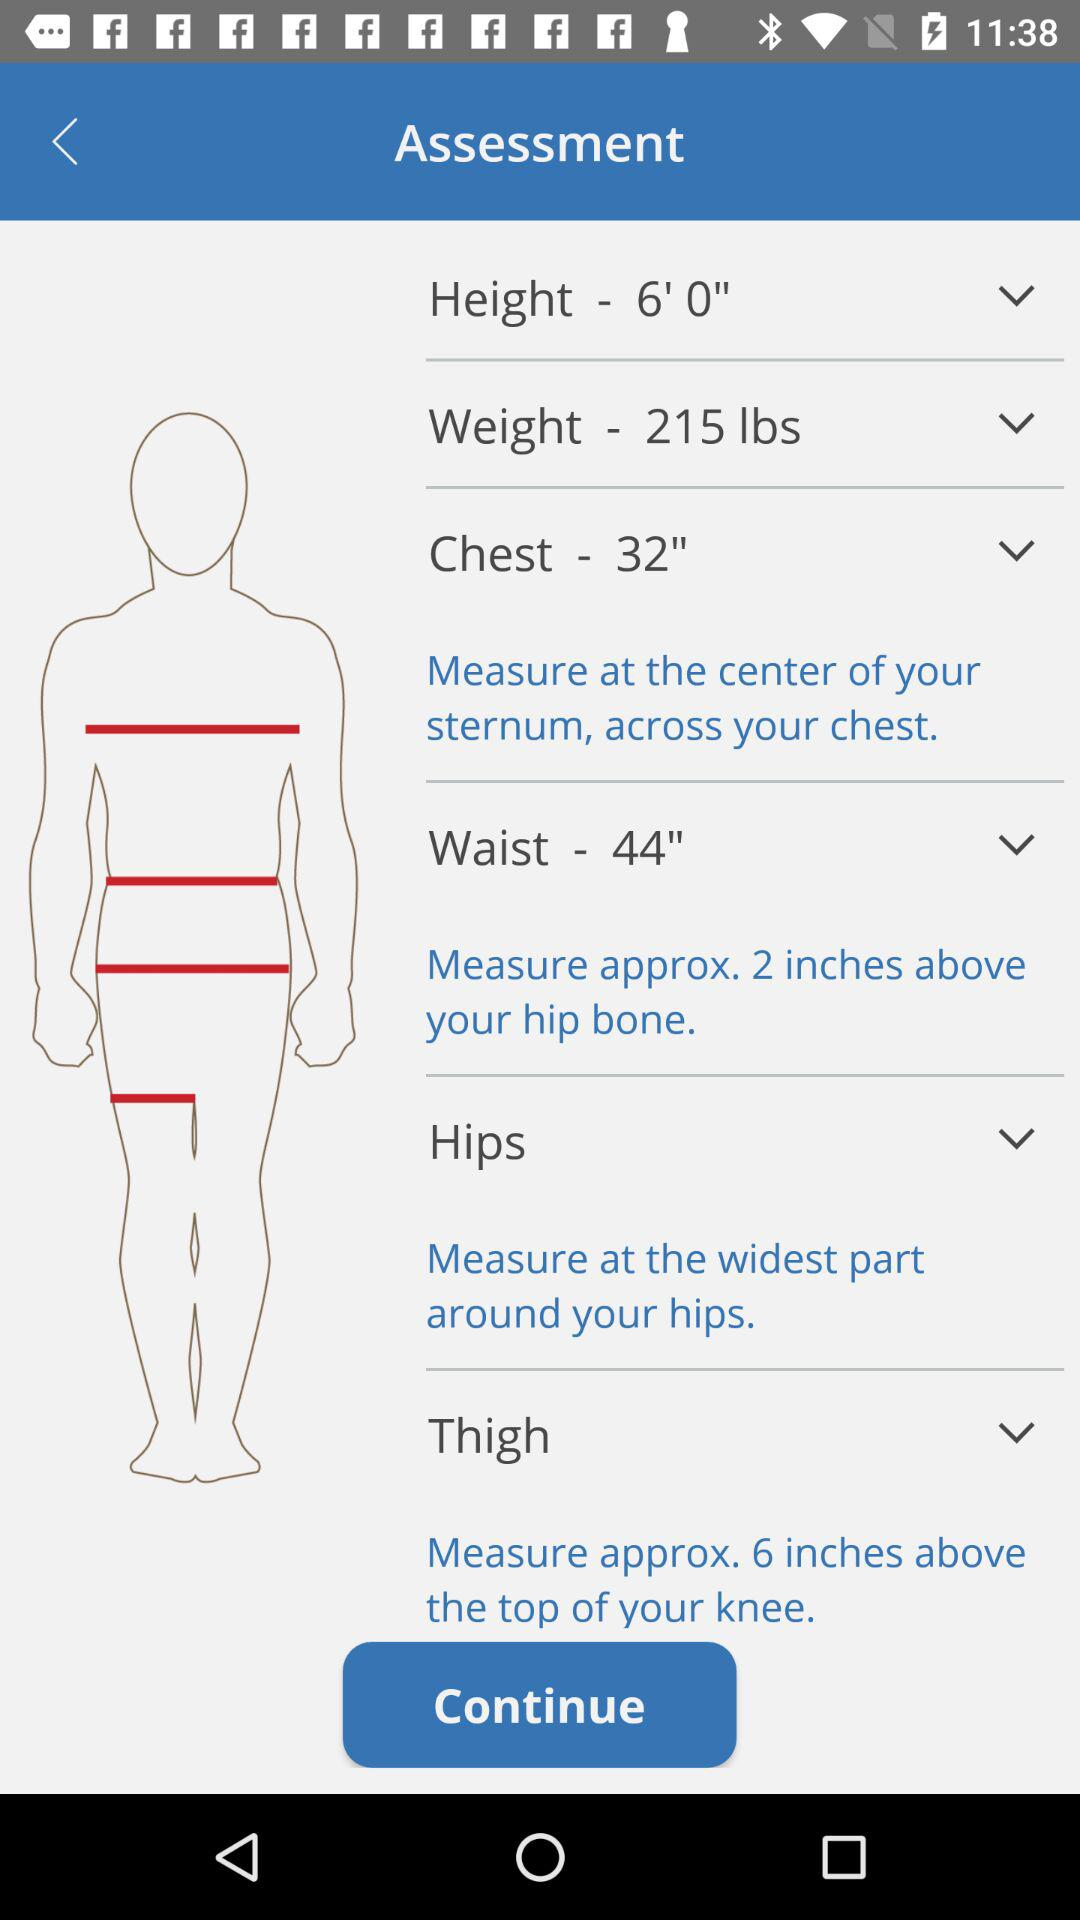What is the given waist size? The given waist size is 44 inches. 